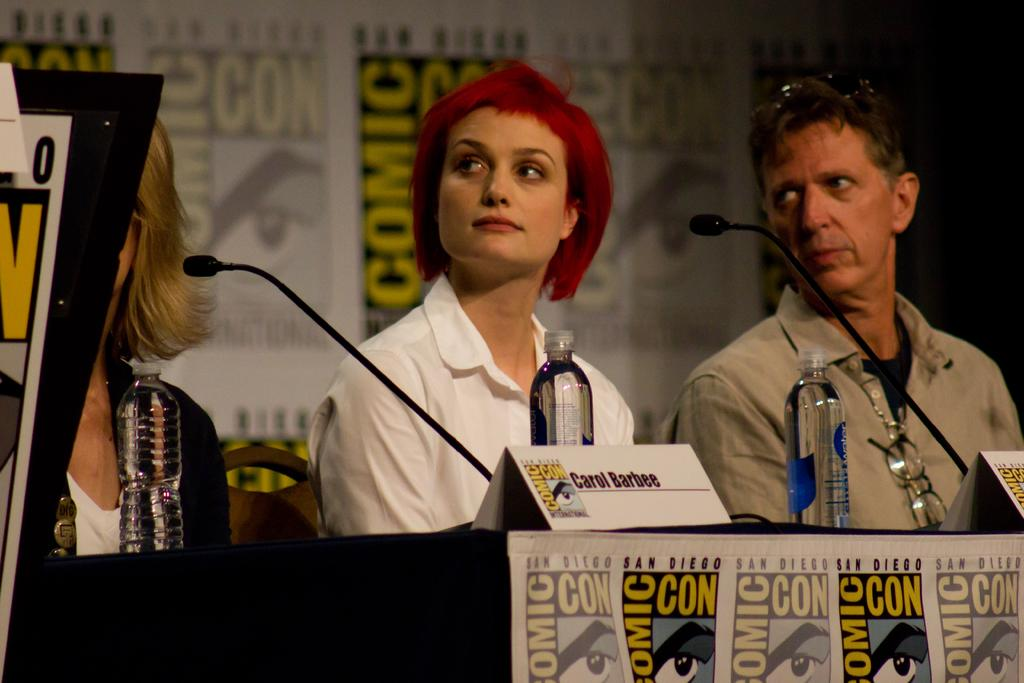How many people are in the image? There is a man and two women in the image. What are the people in the image doing? The man and women are sitting on chairs. What objects can be seen in the image related to communication? There are mics in the image. What other items are visible in the image? There are bottles in the image. What event or theme is suggested by the phrase written in multiple places in the image? The phrase "comic con" suggests that the image is related to a comic convention. What type of pie is being served to the man in the image? There is no pie present in the image. How many loaves of bread can be seen on the table in the image? There are no loaves of bread visible in the image. 